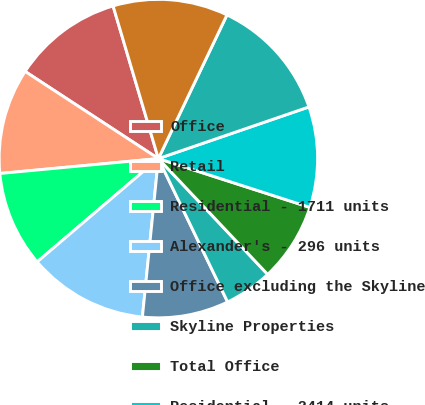Convert chart. <chart><loc_0><loc_0><loc_500><loc_500><pie_chart><fcel>Office<fcel>Retail<fcel>Residential - 1711 units<fcel>Alexander's - 296 units<fcel>Office excluding the Skyline<fcel>Skyline Properties<fcel>Total Office<fcel>Residential - 2414 units<fcel>Other<fcel>theMart<nl><fcel>11.19%<fcel>10.71%<fcel>9.74%<fcel>12.17%<fcel>8.76%<fcel>4.88%<fcel>8.0%<fcel>10.22%<fcel>12.65%<fcel>11.68%<nl></chart> 